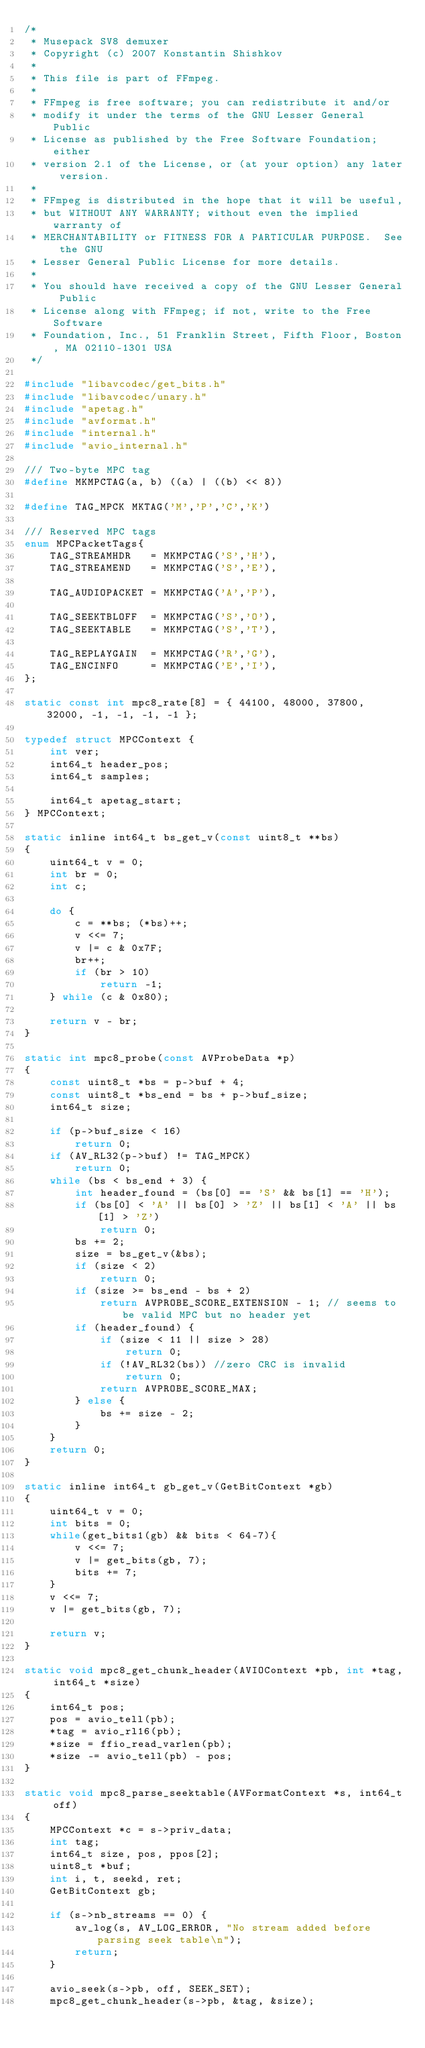Convert code to text. <code><loc_0><loc_0><loc_500><loc_500><_C_>/*
 * Musepack SV8 demuxer
 * Copyright (c) 2007 Konstantin Shishkov
 *
 * This file is part of FFmpeg.
 *
 * FFmpeg is free software; you can redistribute it and/or
 * modify it under the terms of the GNU Lesser General Public
 * License as published by the Free Software Foundation; either
 * version 2.1 of the License, or (at your option) any later version.
 *
 * FFmpeg is distributed in the hope that it will be useful,
 * but WITHOUT ANY WARRANTY; without even the implied warranty of
 * MERCHANTABILITY or FITNESS FOR A PARTICULAR PURPOSE.  See the GNU
 * Lesser General Public License for more details.
 *
 * You should have received a copy of the GNU Lesser General Public
 * License along with FFmpeg; if not, write to the Free Software
 * Foundation, Inc., 51 Franklin Street, Fifth Floor, Boston, MA 02110-1301 USA
 */

#include "libavcodec/get_bits.h"
#include "libavcodec/unary.h"
#include "apetag.h"
#include "avformat.h"
#include "internal.h"
#include "avio_internal.h"

/// Two-byte MPC tag
#define MKMPCTAG(a, b) ((a) | ((b) << 8))

#define TAG_MPCK MKTAG('M','P','C','K')

/// Reserved MPC tags
enum MPCPacketTags{
    TAG_STREAMHDR   = MKMPCTAG('S','H'),
    TAG_STREAMEND   = MKMPCTAG('S','E'),

    TAG_AUDIOPACKET = MKMPCTAG('A','P'),

    TAG_SEEKTBLOFF  = MKMPCTAG('S','O'),
    TAG_SEEKTABLE   = MKMPCTAG('S','T'),

    TAG_REPLAYGAIN  = MKMPCTAG('R','G'),
    TAG_ENCINFO     = MKMPCTAG('E','I'),
};

static const int mpc8_rate[8] = { 44100, 48000, 37800, 32000, -1, -1, -1, -1 };

typedef struct MPCContext {
    int ver;
    int64_t header_pos;
    int64_t samples;

    int64_t apetag_start;
} MPCContext;

static inline int64_t bs_get_v(const uint8_t **bs)
{
    uint64_t v = 0;
    int br = 0;
    int c;

    do {
        c = **bs; (*bs)++;
        v <<= 7;
        v |= c & 0x7F;
        br++;
        if (br > 10)
            return -1;
    } while (c & 0x80);

    return v - br;
}

static int mpc8_probe(const AVProbeData *p)
{
    const uint8_t *bs = p->buf + 4;
    const uint8_t *bs_end = bs + p->buf_size;
    int64_t size;

    if (p->buf_size < 16)
        return 0;
    if (AV_RL32(p->buf) != TAG_MPCK)
        return 0;
    while (bs < bs_end + 3) {
        int header_found = (bs[0] == 'S' && bs[1] == 'H');
        if (bs[0] < 'A' || bs[0] > 'Z' || bs[1] < 'A' || bs[1] > 'Z')
            return 0;
        bs += 2;
        size = bs_get_v(&bs);
        if (size < 2)
            return 0;
        if (size >= bs_end - bs + 2)
            return AVPROBE_SCORE_EXTENSION - 1; // seems to be valid MPC but no header yet
        if (header_found) {
            if (size < 11 || size > 28)
                return 0;
            if (!AV_RL32(bs)) //zero CRC is invalid
                return 0;
            return AVPROBE_SCORE_MAX;
        } else {
            bs += size - 2;
        }
    }
    return 0;
}

static inline int64_t gb_get_v(GetBitContext *gb)
{
    uint64_t v = 0;
    int bits = 0;
    while(get_bits1(gb) && bits < 64-7){
        v <<= 7;
        v |= get_bits(gb, 7);
        bits += 7;
    }
    v <<= 7;
    v |= get_bits(gb, 7);

    return v;
}

static void mpc8_get_chunk_header(AVIOContext *pb, int *tag, int64_t *size)
{
    int64_t pos;
    pos = avio_tell(pb);
    *tag = avio_rl16(pb);
    *size = ffio_read_varlen(pb);
    *size -= avio_tell(pb) - pos;
}

static void mpc8_parse_seektable(AVFormatContext *s, int64_t off)
{
    MPCContext *c = s->priv_data;
    int tag;
    int64_t size, pos, ppos[2];
    uint8_t *buf;
    int i, t, seekd, ret;
    GetBitContext gb;

    if (s->nb_streams == 0) {
        av_log(s, AV_LOG_ERROR, "No stream added before parsing seek table\n");
        return;
    }

    avio_seek(s->pb, off, SEEK_SET);
    mpc8_get_chunk_header(s->pb, &tag, &size);</code> 